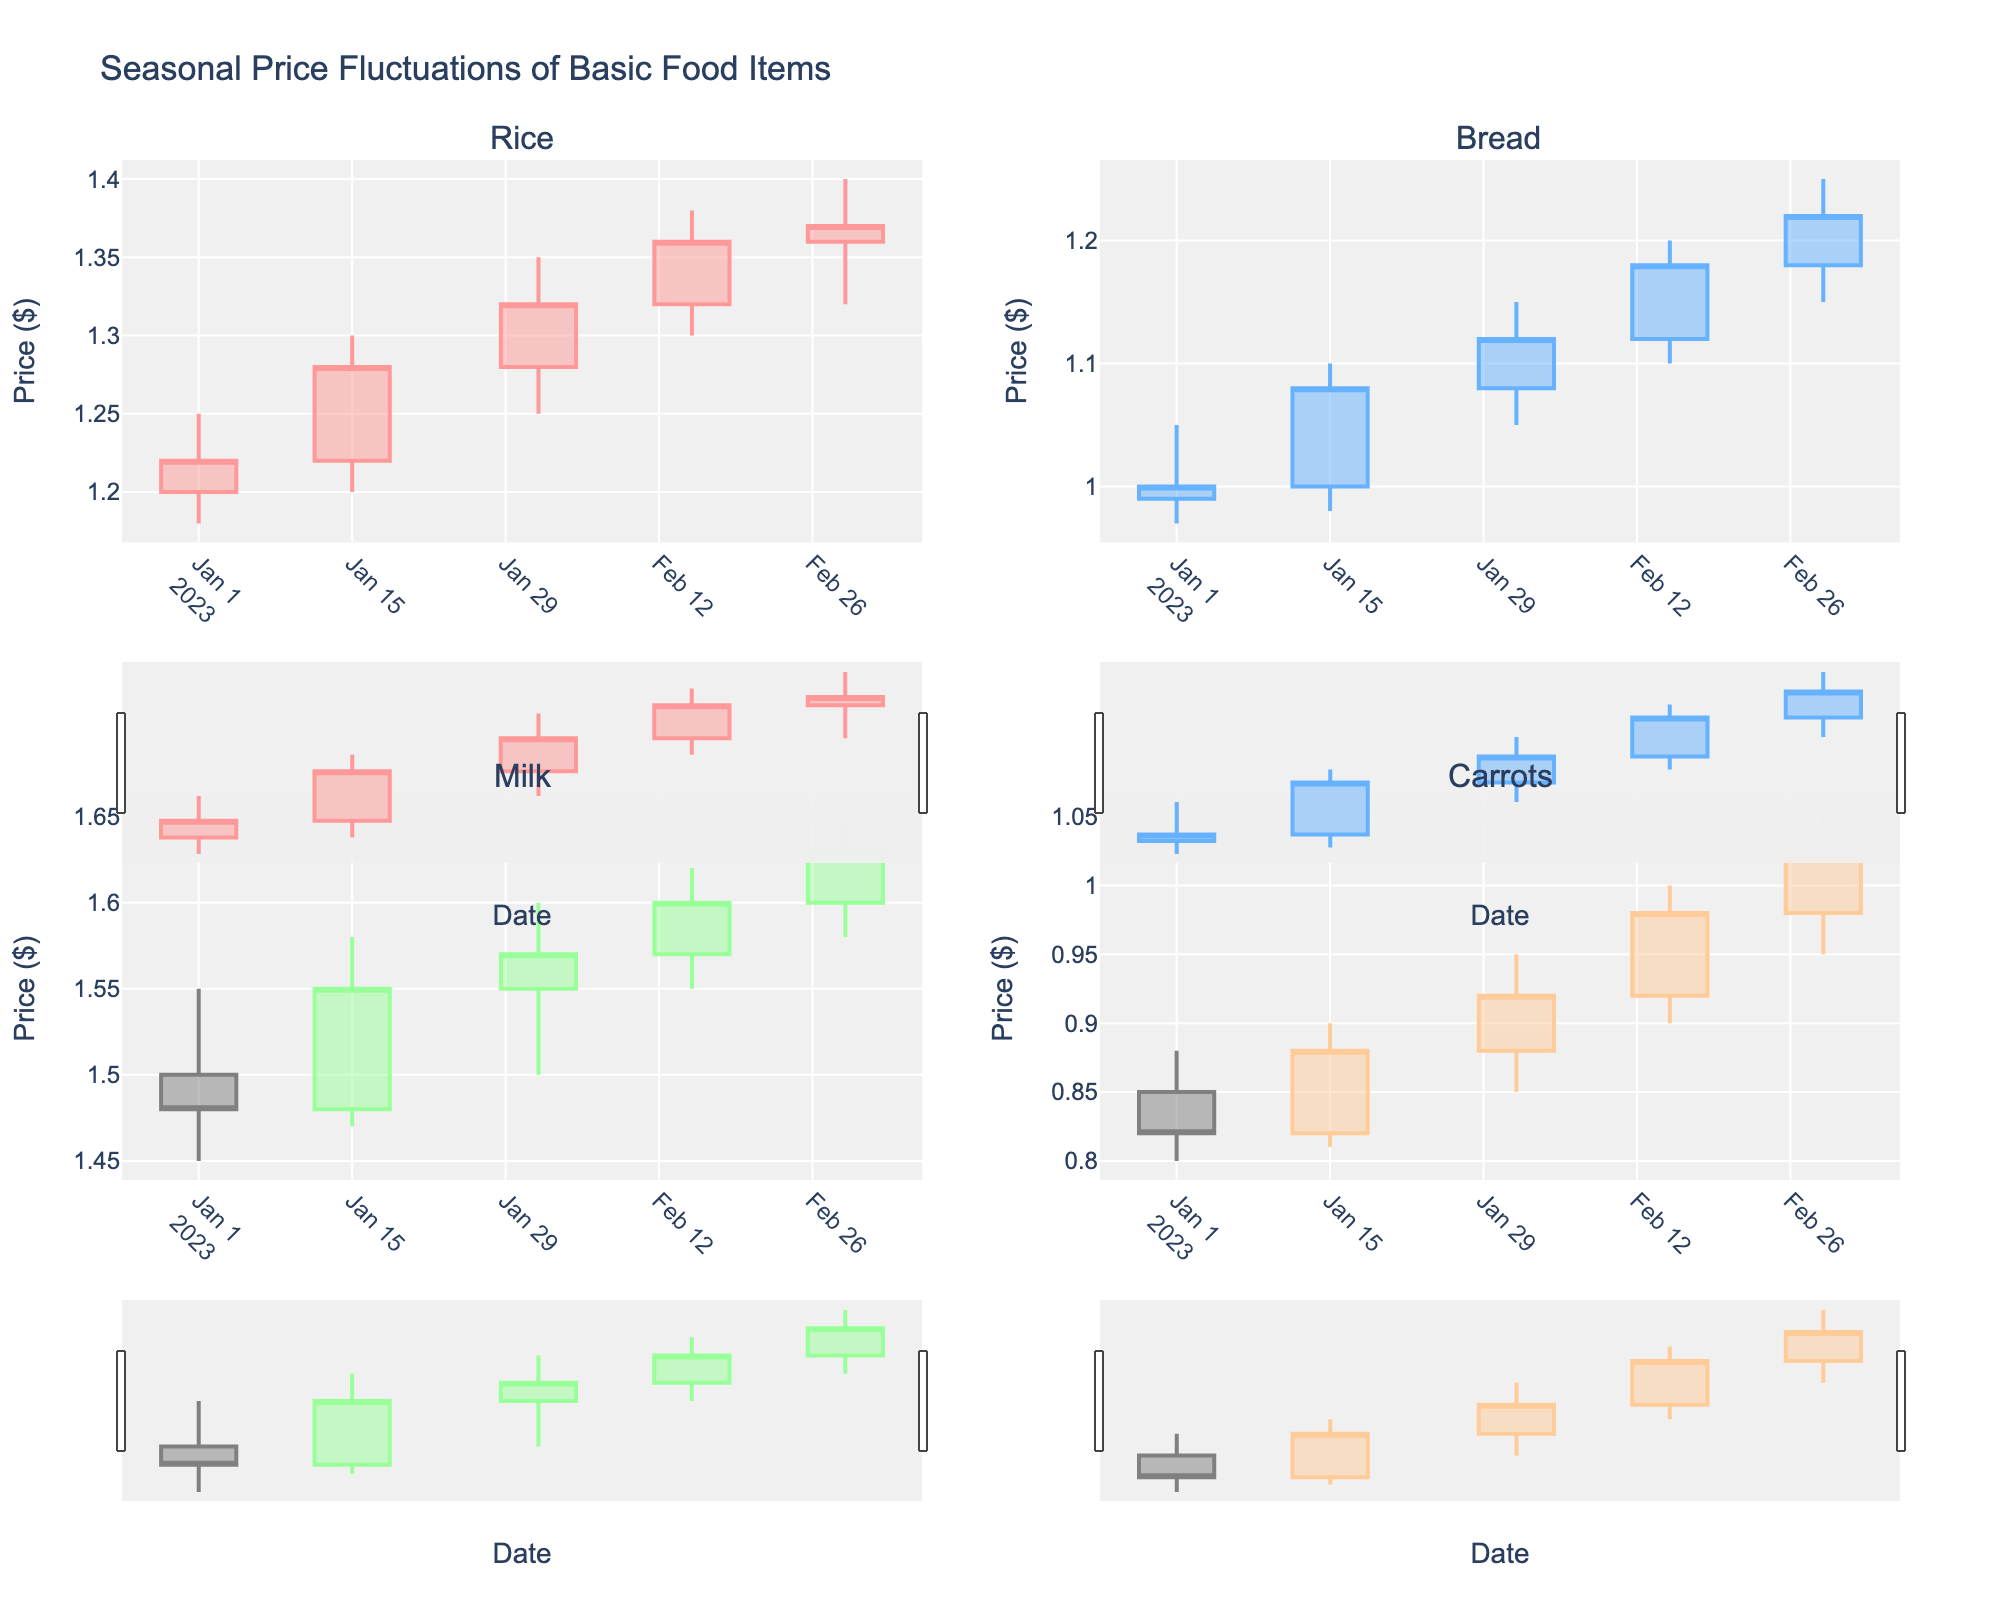What is the title of the plot? The title is at the top of the figure.
Answer: Seasonal Price Fluctuations of Basic Food Items How many subplots are there in the figure? The figure is divided into sections, each representing a different food item. The total number of these sections is the number of subplots.
Answer: 4 Which season shows an increasing trend in the price of Milk? By observing the candlestick for Milk, note the directional trends and determine the season correlated with these trends.
Answer: Winter (Jan-Mar) What is the highest price reached by Carrots? Check the highest point (upper wick) for the Carrots candlestick.
Answer: $1.05 Between Rice and Bread, which food item experienced a higher variability in price? Compare the ranges within the candlesticks for Rice and Bread prices to determine which shows more fluctuation.
Answer: Rice What is the overall trend for Bread prices over the observed period? Observe the sequence of candlesticks for Bread to determine the overall movement direction of its closing prices.
Answer: Increasing Compare the closing prices of Milk in January and March. Which month had a higher closing price? Compare the closing prices on the candlestick chart for Milk at these two time points.
Answer: March What is the median closing price for Rice over the two months of January and February? To find the median, list the closing prices in order: $1.22, $1.28, $1.32, $1.36. The median will be the average of the two middle numbers.
Answer: $1.30 What date did Milk reach a price of $1.65? Locate the date where the upper wick of the Milk candlestick touches $1.65.
Answer: March 1, 2023 Which food item's price increased the most from January 1 to March 1? Calculate the increase by subtracting the opening price on January 1 from the closing price on March 1 for each food item. Compare these values to identify the greatest increase.
Answer: Carrots 